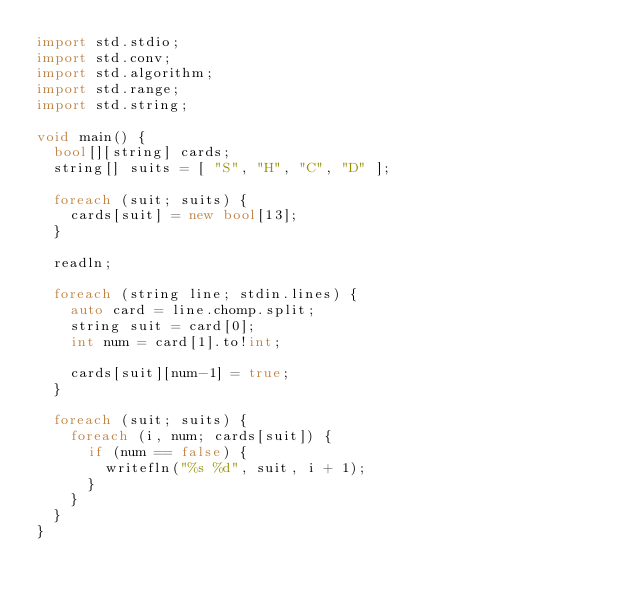Convert code to text. <code><loc_0><loc_0><loc_500><loc_500><_D_>import std.stdio;
import std.conv;
import std.algorithm;
import std.range;
import std.string;

void main() {
  bool[][string] cards;
  string[] suits = [ "S", "H", "C", "D" ];

  foreach (suit; suits) {
    cards[suit] = new bool[13];
  }

  readln;

  foreach (string line; stdin.lines) {
    auto card = line.chomp.split;
    string suit = card[0];
    int num = card[1].to!int;

    cards[suit][num-1] = true;
  }

  foreach (suit; suits) {
    foreach (i, num; cards[suit]) {
      if (num == false) {
        writefln("%s %d", suit, i + 1);
      }
    }
  }
}</code> 